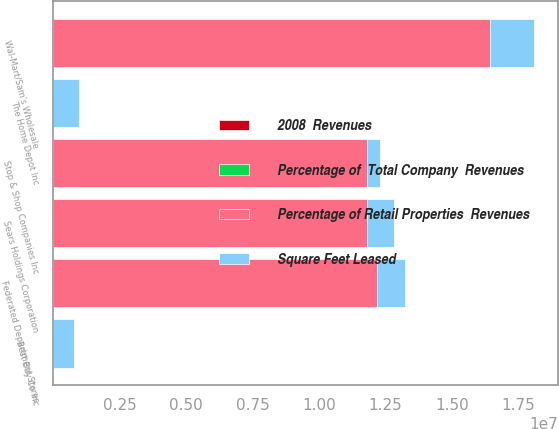<chart> <loc_0><loc_0><loc_500><loc_500><stacked_bar_chart><ecel><fcel>The Home Depot Inc<fcel>Best Buy Co Inc<fcel>Wal-Mart/Sam's Wholesale<fcel>Federated Department Stores<fcel>Sears Holdings Corporation<fcel>Stop & Shop Companies Inc<nl><fcel>Square Feet Leased<fcel>990000<fcel>795000<fcel>1.667e+06<fcel>1.08e+06<fcel>1.012e+06<fcel>498000<nl><fcel>Percentage of Retail Properties  Revenues<fcel>3.3<fcel>3.3<fcel>1.6417e+07<fcel>1.2167e+07<fcel>1.1815e+07<fcel>1.1793e+07<nl><fcel>2008  Revenues<fcel>3.3<fcel>3.3<fcel>3.1<fcel>2.3<fcel>2.2<fcel>2.2<nl><fcel>Percentage of  Total Company  Revenues<fcel>0.7<fcel>0.7<fcel>0.6<fcel>0.5<fcel>0.4<fcel>0.4<nl></chart> 